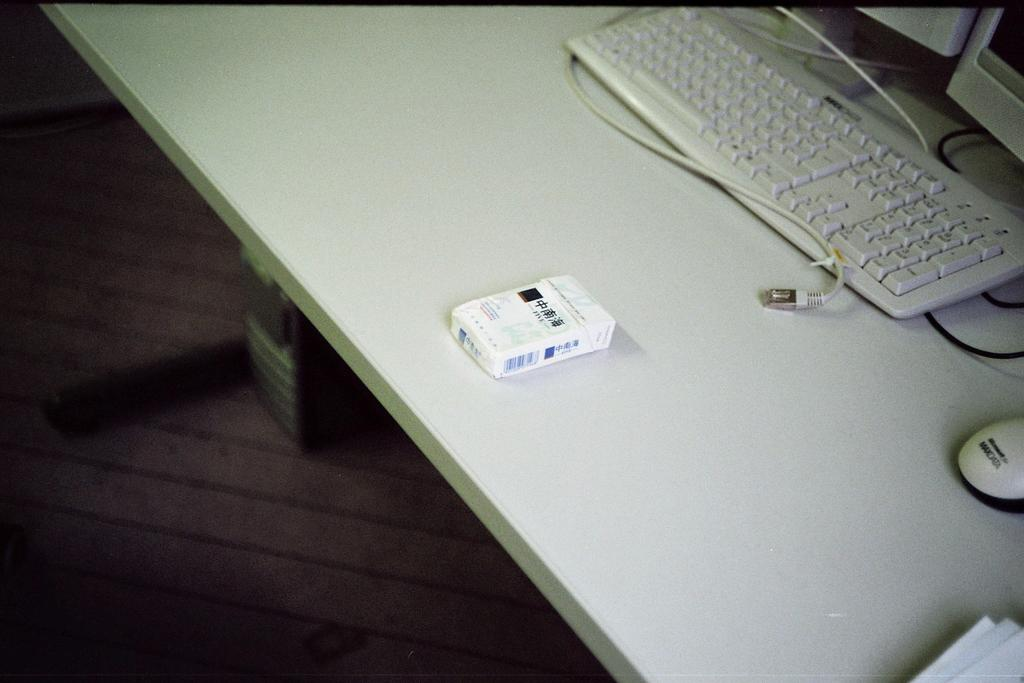Provide a one-sentence caption for the provided image. The pack of cigarettes are near the Maxdata mouse. 